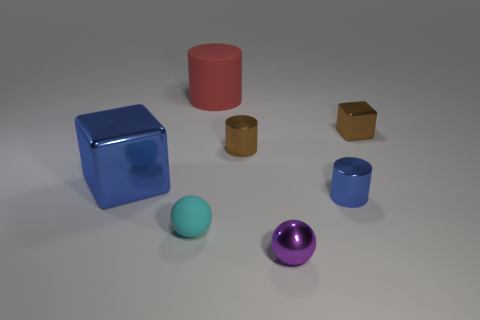What can you infer about the lighting in this scene? The lighting in the scene appears to come from the top, casting soft shadows directly underneath each object. This arrangement suggests a diffuse or possibly studio lighting setup, aimed at highlighting the shapes and materials of the objects with minimal harsh shadows. 